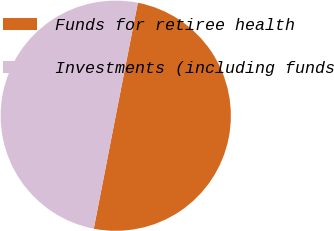Convert chart to OTSL. <chart><loc_0><loc_0><loc_500><loc_500><pie_chart><fcel>Funds for retiree health<fcel>Investments (including funds<nl><fcel>49.98%<fcel>50.02%<nl></chart> 